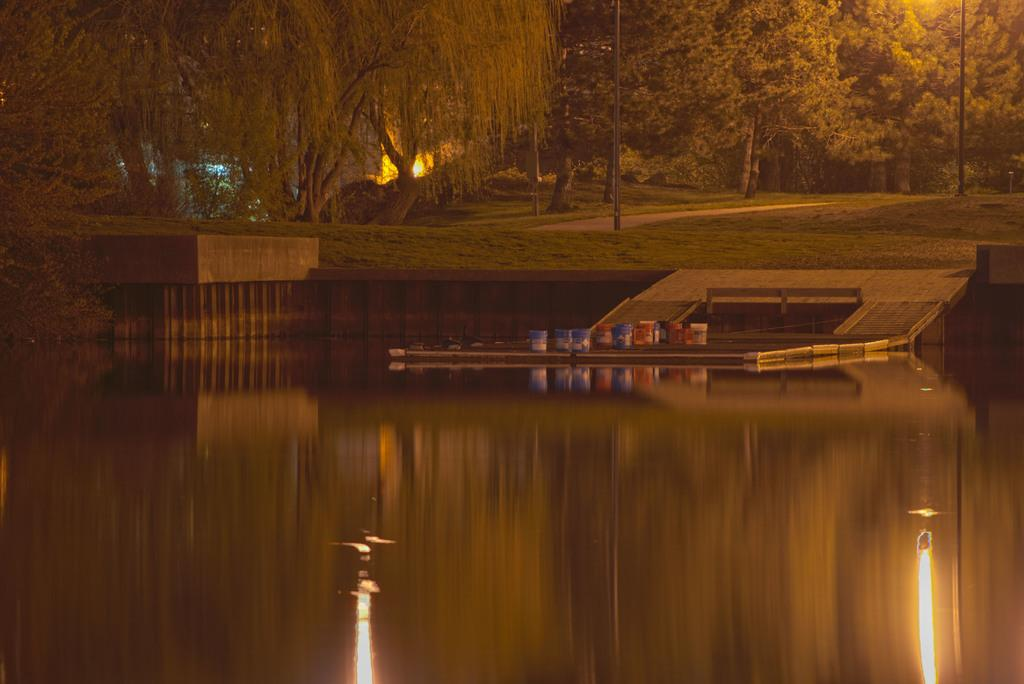What type of natural feature is present in the image? There is a river in the image. What type of vegetation can be seen in the image? There is grass and trees in the image. What man-made object is present in the image? There is a pole in the image. What is on the ground in the image? There are objects on the floor in the image. How many leaves are on the lumber in the image? There is no lumber or leaves present in the image. 